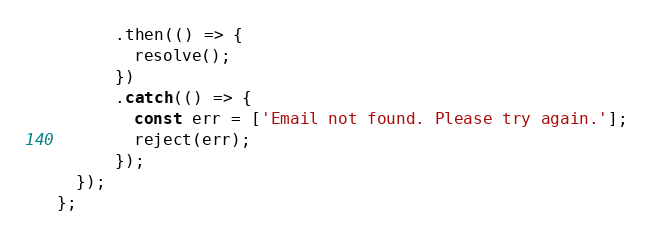<code> <loc_0><loc_0><loc_500><loc_500><_JavaScript_>      .then(() => {
        resolve();
      })
      .catch(() => {
        const err = ['Email not found. Please try again.'];
        reject(err);
      });
  });
};
</code> 